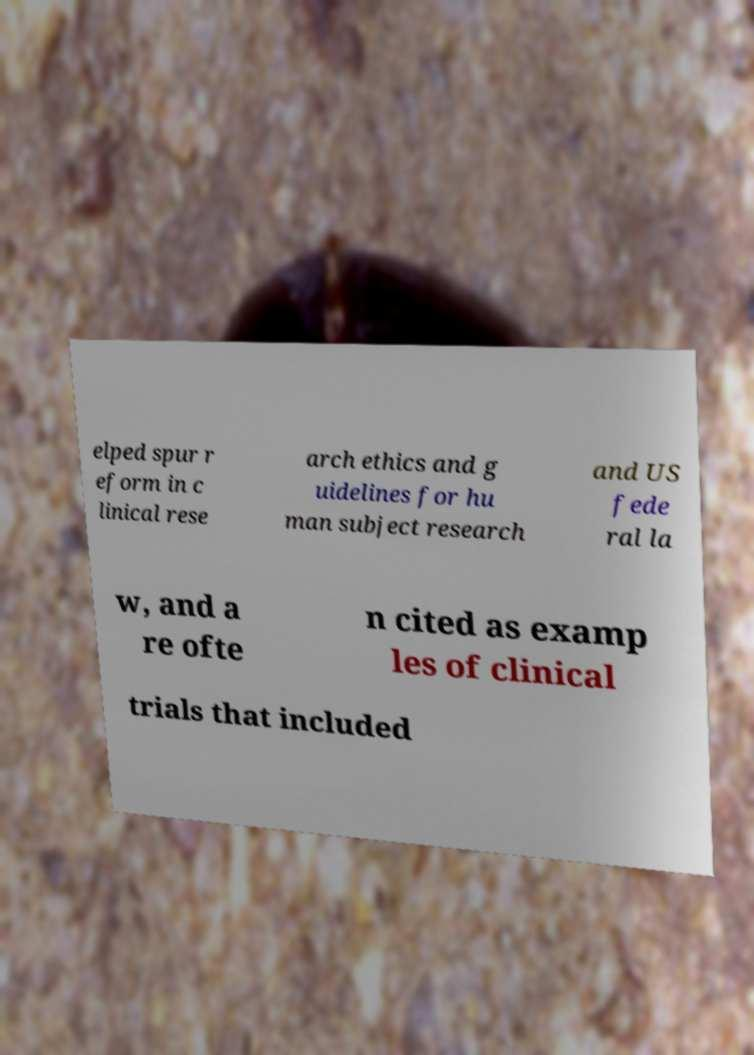There's text embedded in this image that I need extracted. Can you transcribe it verbatim? elped spur r eform in c linical rese arch ethics and g uidelines for hu man subject research and US fede ral la w, and a re ofte n cited as examp les of clinical trials that included 